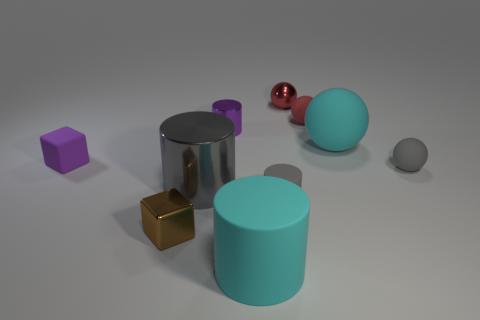Is the number of purple matte cubes greater than the number of big blue rubber cylinders?
Your answer should be compact. Yes. What color is the tiny cube to the right of the purple rubber cube?
Make the answer very short. Brown. How big is the matte object that is both behind the cyan cylinder and in front of the big metal cylinder?
Keep it short and to the point. Small. What number of cyan spheres have the same size as the brown thing?
Your response must be concise. 0. What is the material of the cyan thing that is the same shape as the tiny purple metallic object?
Keep it short and to the point. Rubber. Is the tiny purple matte thing the same shape as the small brown thing?
Your answer should be compact. Yes. How many tiny rubber balls are in front of the tiny red rubber object?
Make the answer very short. 1. There is a small purple object in front of the large cyan object right of the large cyan cylinder; what is its shape?
Provide a short and direct response. Cube. The purple object that is the same material as the big cyan cylinder is what shape?
Provide a succinct answer. Cube. There is a purple thing that is behind the small rubber cube; is it the same size as the gray matte object in front of the big gray metallic object?
Provide a short and direct response. Yes. 